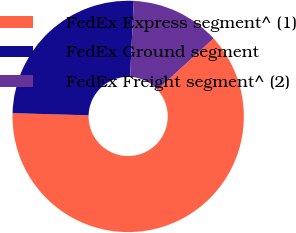<chart> <loc_0><loc_0><loc_500><loc_500><pie_chart><fcel>FedEx Express segment^ (1)<fcel>FedEx Ground segment<fcel>FedEx Freight segment^ (2)<nl><fcel>62.23%<fcel>25.32%<fcel>12.45%<nl></chart> 